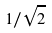<formula> <loc_0><loc_0><loc_500><loc_500>1 / \sqrt { 2 }</formula> 